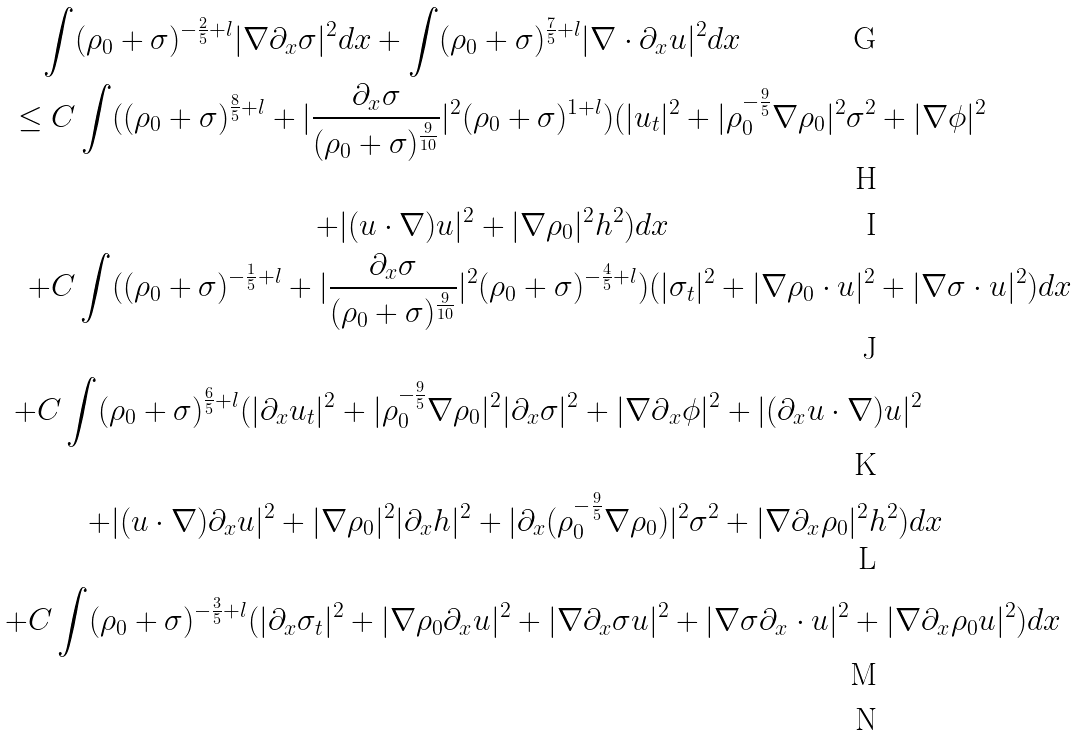Convert formula to latex. <formula><loc_0><loc_0><loc_500><loc_500>\int ( \rho _ { 0 } + \sigma ) ^ { - \frac { 2 } { 5 } + l } | \nabla \partial _ { x } \sigma | ^ { 2 } d x + \int ( \rho _ { 0 } + \sigma ) ^ { \frac { 7 } { 5 } + l } | \nabla \cdot \partial _ { x } & u | ^ { 2 } d x \\ \leq C \int ( ( \rho _ { 0 } + \sigma ) ^ { \frac { 8 } { 5 } + l } + | \frac { \partial _ { x } \sigma } { ( \rho _ { 0 } + \sigma ) ^ { \frac { 9 } { 1 0 } } } | ^ { 2 } ( \rho _ { 0 } + \sigma ) ^ { 1 + l } ) ( | u _ { t } | & ^ { 2 } + | \rho _ { 0 } ^ { - \frac { 9 } { 5 } } \nabla \rho _ { 0 } | ^ { 2 } \sigma ^ { 2 } + | \nabla \phi | ^ { 2 } \\ + | ( u \cdot \nabla ) u | ^ { 2 } + | \nabla \rho _ { 0 } | ^ { 2 } h ^ { 2 } ) d x \\ + C \int ( ( \rho _ { 0 } + \sigma ) ^ { - \frac { 1 } { 5 } + l } + | \frac { \partial _ { x } \sigma } { ( \rho _ { 0 } + \sigma ) ^ { \frac { 9 } { 1 0 } } } | ^ { 2 } ( \rho _ { 0 } + \sigma ) ^ { - \frac { 4 } { 5 } + l } ) ( | & \sigma _ { t } | ^ { 2 } + | \nabla \rho _ { 0 } \cdot u | ^ { 2 } + | \nabla \sigma \cdot u | ^ { 2 } ) d x \\ + C \int ( \rho _ { 0 } + \sigma ) ^ { \frac { 6 } { 5 } + l } ( | \partial _ { x } u _ { t } | ^ { 2 } + | \rho _ { 0 } ^ { - \frac { 9 } { 5 } } \nabla \rho _ { 0 } | ^ { 2 } | \partial _ { x } \sigma | ^ { 2 } + | \nabla \partial & _ { x } \phi | ^ { 2 } + | ( \partial _ { x } u \cdot \nabla ) u | ^ { 2 } \\ + | ( u \cdot \nabla ) \partial _ { x } u | ^ { 2 } + | \nabla \rho _ { 0 } | ^ { 2 } | \partial _ { x } h | ^ { 2 } + | \partial _ { x } ( \rho _ { 0 } ^ { - \frac { 9 } { 5 } } \nabla \rho _ { 0 } ) & | ^ { 2 } \sigma ^ { 2 } + | \nabla \partial _ { x } \rho _ { 0 } | ^ { 2 } h ^ { 2 } ) d x \\ + C \int ( \rho _ { 0 } + \sigma ) ^ { - \frac { 3 } { 5 } + l } ( | \partial _ { x } \sigma _ { t } | ^ { 2 } + | \nabla \rho _ { 0 } \partial _ { x } u | ^ { 2 } + | \nabla \partial _ { x } \sigma u | ^ { 2 } & + | \nabla \sigma \partial _ { x } \cdot u | ^ { 2 } + | \nabla \partial _ { x } \rho _ { 0 } u | ^ { 2 } ) d x \\</formula> 